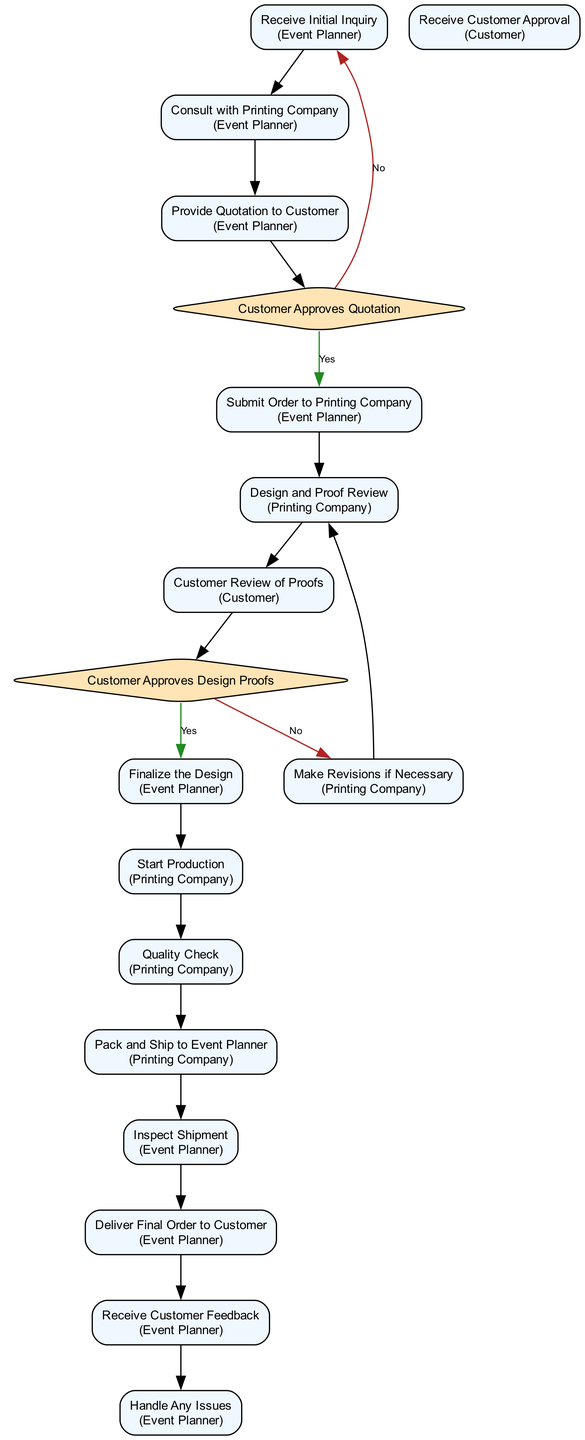What is the first activity in the diagram? The first activity listed is "Receive Initial Inquiry", which is where the process starts and involves collecting details about the customer's personalization requirements.
Answer: Receive Initial Inquiry How many decision points are present in the diagram? There are two decision points in the diagram: "Customer Approves Quotation" and "Customer Approves Design Proofs", which indicate where decisions must be made based on customer feedback.
Answer: 2 What is the final activity in the process? The last activity recorded in the flow is "Handle Any Issues", which involves addressing and resolving any problems reported by the customer after they receive their order.
Answer: Handle Any Issues What happens if the customer does not approve the quotation? If the customer does not approve the quotation, the flow returns to "Receive Initial Inquiry", indicating that the process will restart from gathering the customer's requirements.
Answer: Receive Initial Inquiry How many activities are associated with the printing company? There are five activities involving the printing company: "Design and Proof Review", "Customer Review of Proofs", "Make Revisions if Necessary", "Start Production", and "Quality Check". These activities focus on the design and production processes.
Answer: 5 What is the role of the event planner in this diagram? The event planner plays a critical role throughout the process, from receiving inquiries, consulting with the printing company, submitting orders, finalizing designs, to delivering the final orders to customers and addressing feedback.
Answer: Event Planner What occurs after "Pack and Ship to Event Planner"? After "Pack and Ship to Event Planner", the next step is "Inspect Shipment", where the event planner checks the received merchandise for completeness and quality before delivery.
Answer: Inspect Shipment Overall, how many flows are depicted in the diagram? The diagram contains a total of fifteen flows that describe the sequence and decision-making process from the initial inquiry to final delivery, showing various paths the process can take.
Answer: 15 